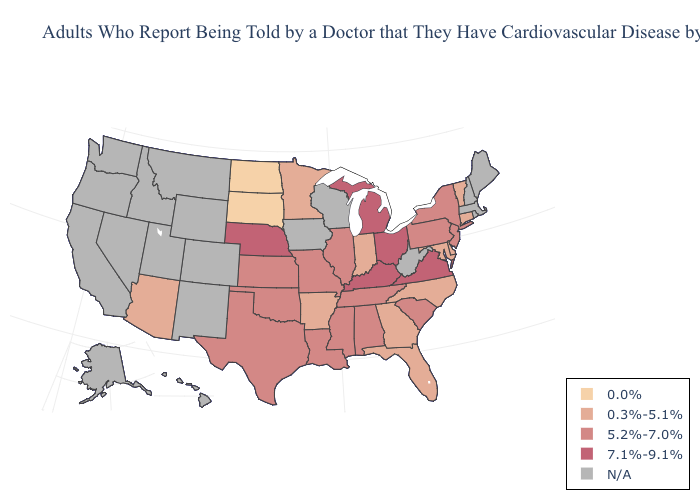Which states have the lowest value in the USA?
Be succinct. North Dakota, South Dakota. What is the value of Nevada?
Be succinct. N/A. What is the highest value in the South ?
Give a very brief answer. 7.1%-9.1%. What is the highest value in the South ?
Write a very short answer. 7.1%-9.1%. What is the lowest value in the MidWest?
Keep it brief. 0.0%. What is the value of Washington?
Give a very brief answer. N/A. Does Ohio have the highest value in the USA?
Concise answer only. Yes. How many symbols are there in the legend?
Be succinct. 5. Which states hav the highest value in the Northeast?
Answer briefly. New Jersey, New York, Pennsylvania. Name the states that have a value in the range 5.2%-7.0%?
Give a very brief answer. Alabama, Illinois, Kansas, Louisiana, Mississippi, Missouri, New Jersey, New York, Oklahoma, Pennsylvania, South Carolina, Tennessee, Texas. What is the value of Louisiana?
Write a very short answer. 5.2%-7.0%. Does Connecticut have the lowest value in the Northeast?
Concise answer only. Yes. Name the states that have a value in the range N/A?
Give a very brief answer. Alaska, California, Colorado, Hawaii, Idaho, Iowa, Maine, Massachusetts, Montana, Nevada, New Hampshire, New Mexico, Oregon, Rhode Island, Utah, Washington, West Virginia, Wisconsin, Wyoming. 